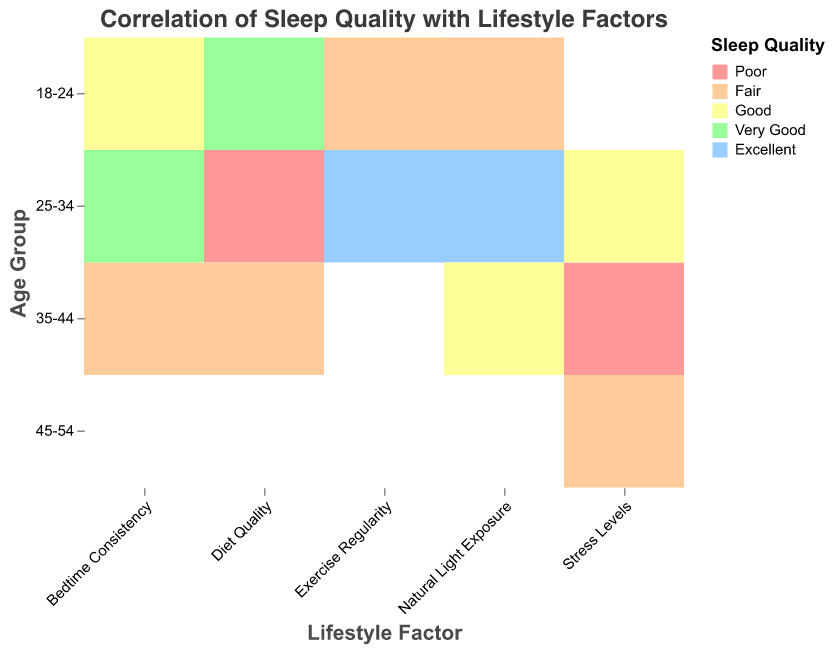What is the title of the heatmap? The title of the heatmap is located at the top of the plot. The title text is in large font size and reads "Correlation of Sleep Quality with Lifestyle Factors".
Answer: Correlation of Sleep Quality with Lifestyle Factors Which age group has the most data points associated with "Natural Light Exposure"? To find the age group with the most data points for "Natural Light Exposure," look at how many cells in the "Natural Light Exposure" column match different age groups.
Answer: 25-34 What sleep quality is most associated with the "Exercise Regularity" lifestyle factor? Look at the cells under the "Exercise Regularity" column and observe the corresponding sleep quality color or label. "Exercise Regularity" has "Good," "Fair," and "Excellent." Determine which one appears the most frequently.
Answer: Fair Which lifestyle factor shows "Poor" sleep quality for the age group 25-34? Find the cell with "Poor" sleep quality color or label in the 25-34 row and note the corresponding lifestyle factor.
Answer: Diet Quality What is the average sleep duration for the "Diet Quality" lifestyle factor? Identify the sleep durations for all entries under "Diet Quality": 8, 5, and 6.5 hours. Calculate the average: (8 + 5 + 6.5) / 3 = 19.5 / 3.
Answer: 6.5 hours How many age groups have "Excellent" sleep quality? Count the number of unique age groups (18-24, 25-34, 35-44, 45-54) associated with the color or label representing "Excellent" sleep quality.
Answer: 2 Which age group has the maximum "Average Step Count" for "Bedtime Consistency"? Look at the cells in the "Bedtime Consistency" column and find the maximum value for "Average Step Count" in the corresponding age group.
Answer: 25-34 